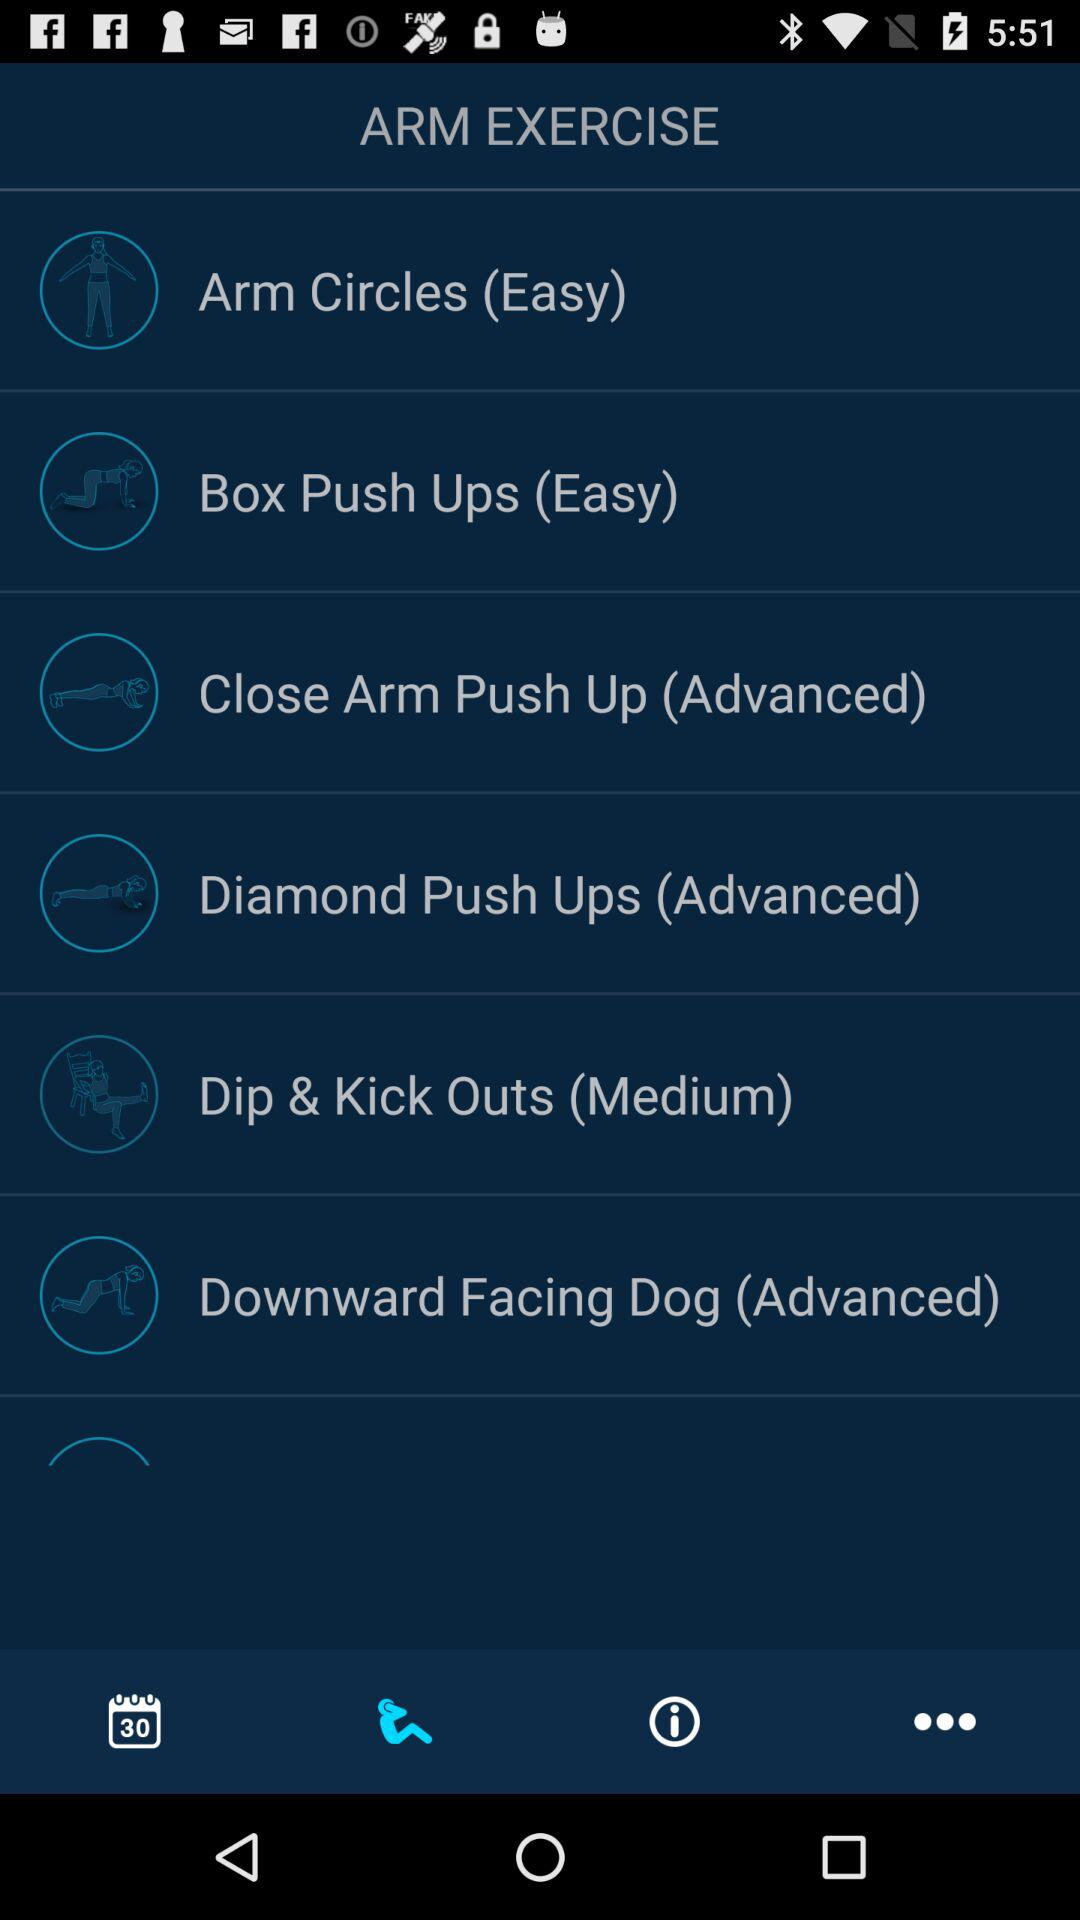What is the percentage of the lesson that has been completed?
Answer the question using a single word or phrase. 0% 